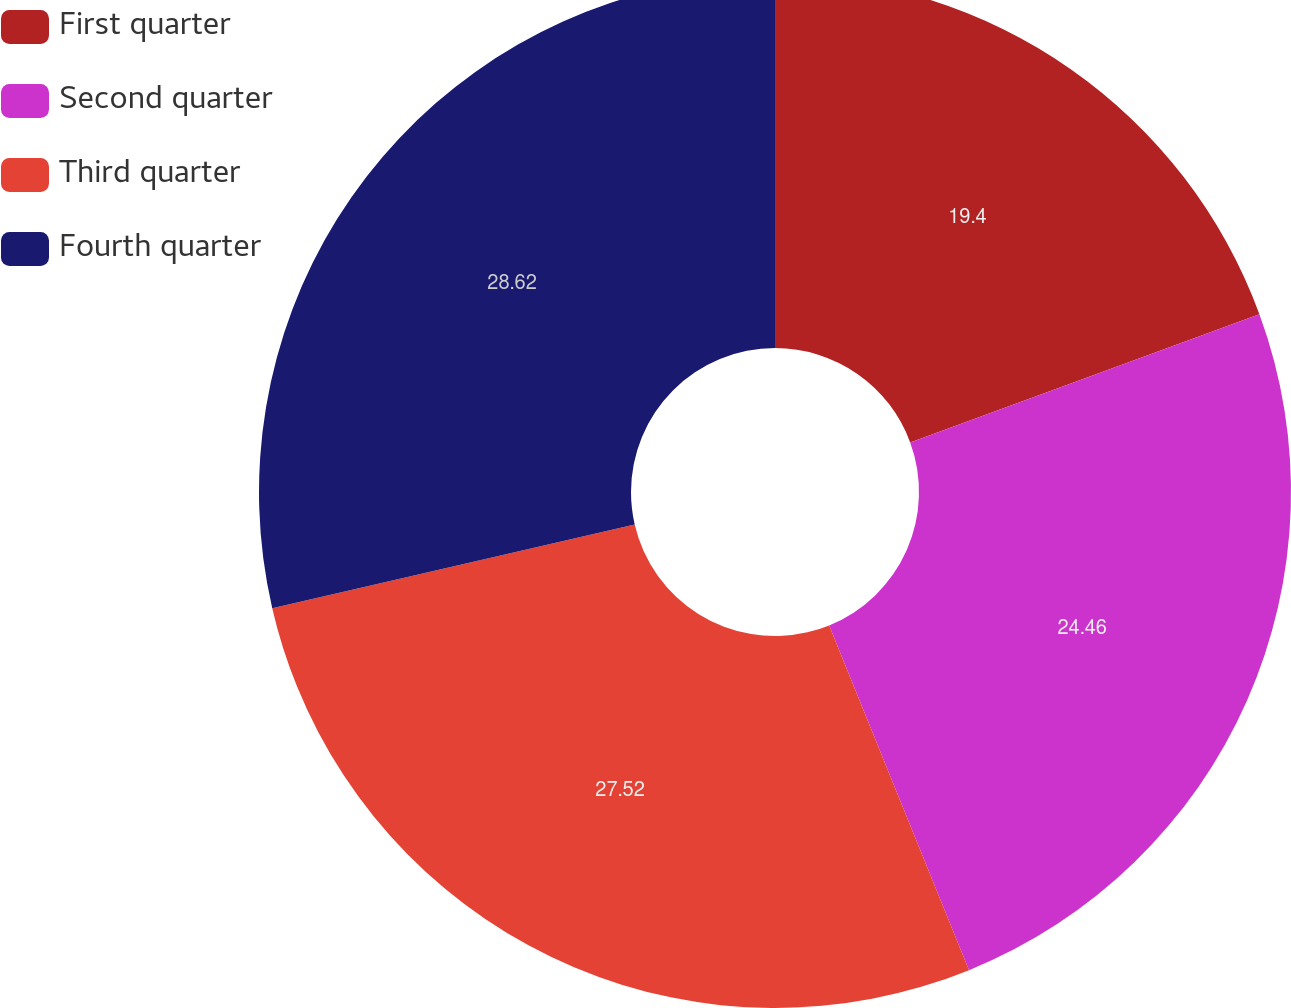Convert chart to OTSL. <chart><loc_0><loc_0><loc_500><loc_500><pie_chart><fcel>First quarter<fcel>Second quarter<fcel>Third quarter<fcel>Fourth quarter<nl><fcel>19.4%<fcel>24.46%<fcel>27.52%<fcel>28.61%<nl></chart> 